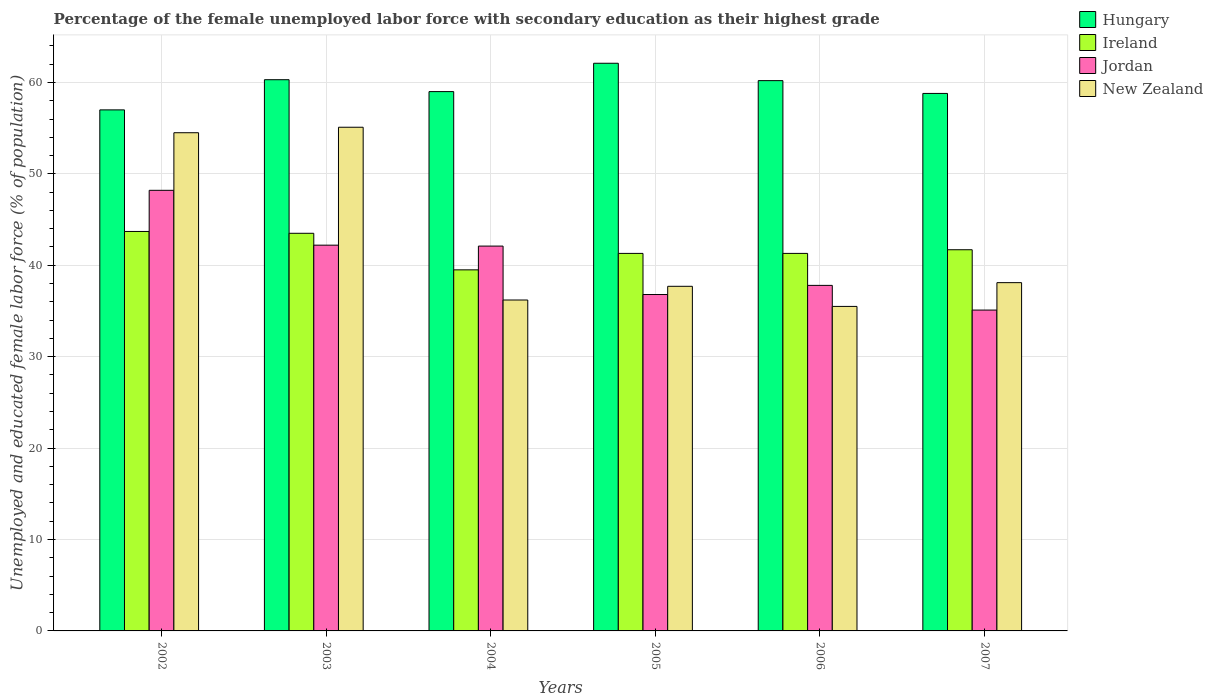How many bars are there on the 4th tick from the left?
Your answer should be very brief. 4. What is the label of the 5th group of bars from the left?
Your response must be concise. 2006. In how many cases, is the number of bars for a given year not equal to the number of legend labels?
Your answer should be compact. 0. What is the percentage of the unemployed female labor force with secondary education in Hungary in 2006?
Make the answer very short. 60.2. Across all years, what is the maximum percentage of the unemployed female labor force with secondary education in Ireland?
Provide a succinct answer. 43.7. In which year was the percentage of the unemployed female labor force with secondary education in New Zealand maximum?
Keep it short and to the point. 2003. What is the total percentage of the unemployed female labor force with secondary education in Hungary in the graph?
Offer a very short reply. 357.4. What is the difference between the percentage of the unemployed female labor force with secondary education in Jordan in 2002 and that in 2006?
Provide a succinct answer. 10.4. What is the difference between the percentage of the unemployed female labor force with secondary education in Ireland in 2007 and the percentage of the unemployed female labor force with secondary education in Jordan in 2004?
Your answer should be very brief. -0.4. What is the average percentage of the unemployed female labor force with secondary education in Jordan per year?
Make the answer very short. 40.37. In the year 2007, what is the difference between the percentage of the unemployed female labor force with secondary education in Ireland and percentage of the unemployed female labor force with secondary education in Hungary?
Your response must be concise. -17.1. In how many years, is the percentage of the unemployed female labor force with secondary education in Jordan greater than 22 %?
Your answer should be compact. 6. What is the ratio of the percentage of the unemployed female labor force with secondary education in Jordan in 2006 to that in 2007?
Your answer should be compact. 1.08. Is the percentage of the unemployed female labor force with secondary education in Jordan in 2003 less than that in 2007?
Keep it short and to the point. No. What is the difference between the highest and the second highest percentage of the unemployed female labor force with secondary education in New Zealand?
Keep it short and to the point. 0.6. What is the difference between the highest and the lowest percentage of the unemployed female labor force with secondary education in Jordan?
Offer a very short reply. 13.1. In how many years, is the percentage of the unemployed female labor force with secondary education in Ireland greater than the average percentage of the unemployed female labor force with secondary education in Ireland taken over all years?
Keep it short and to the point. 2. Is the sum of the percentage of the unemployed female labor force with secondary education in Jordan in 2004 and 2006 greater than the maximum percentage of the unemployed female labor force with secondary education in New Zealand across all years?
Make the answer very short. Yes. What does the 4th bar from the left in 2006 represents?
Ensure brevity in your answer.  New Zealand. What does the 1st bar from the right in 2006 represents?
Keep it short and to the point. New Zealand. Are the values on the major ticks of Y-axis written in scientific E-notation?
Ensure brevity in your answer.  No. Does the graph contain any zero values?
Your response must be concise. No. Does the graph contain grids?
Offer a terse response. Yes. Where does the legend appear in the graph?
Your answer should be compact. Top right. How are the legend labels stacked?
Provide a succinct answer. Vertical. What is the title of the graph?
Give a very brief answer. Percentage of the female unemployed labor force with secondary education as their highest grade. What is the label or title of the Y-axis?
Your response must be concise. Unemployed and educated female labor force (% of population). What is the Unemployed and educated female labor force (% of population) of Ireland in 2002?
Your answer should be compact. 43.7. What is the Unemployed and educated female labor force (% of population) of Jordan in 2002?
Give a very brief answer. 48.2. What is the Unemployed and educated female labor force (% of population) of New Zealand in 2002?
Give a very brief answer. 54.5. What is the Unemployed and educated female labor force (% of population) of Hungary in 2003?
Your answer should be compact. 60.3. What is the Unemployed and educated female labor force (% of population) of Ireland in 2003?
Offer a very short reply. 43.5. What is the Unemployed and educated female labor force (% of population) of Jordan in 2003?
Your answer should be very brief. 42.2. What is the Unemployed and educated female labor force (% of population) of New Zealand in 2003?
Keep it short and to the point. 55.1. What is the Unemployed and educated female labor force (% of population) of Ireland in 2004?
Offer a terse response. 39.5. What is the Unemployed and educated female labor force (% of population) of Jordan in 2004?
Ensure brevity in your answer.  42.1. What is the Unemployed and educated female labor force (% of population) of New Zealand in 2004?
Ensure brevity in your answer.  36.2. What is the Unemployed and educated female labor force (% of population) in Hungary in 2005?
Make the answer very short. 62.1. What is the Unemployed and educated female labor force (% of population) in Ireland in 2005?
Your response must be concise. 41.3. What is the Unemployed and educated female labor force (% of population) of Jordan in 2005?
Offer a very short reply. 36.8. What is the Unemployed and educated female labor force (% of population) of New Zealand in 2005?
Your answer should be very brief. 37.7. What is the Unemployed and educated female labor force (% of population) in Hungary in 2006?
Provide a short and direct response. 60.2. What is the Unemployed and educated female labor force (% of population) of Ireland in 2006?
Your answer should be compact. 41.3. What is the Unemployed and educated female labor force (% of population) of Jordan in 2006?
Make the answer very short. 37.8. What is the Unemployed and educated female labor force (% of population) of New Zealand in 2006?
Your answer should be very brief. 35.5. What is the Unemployed and educated female labor force (% of population) in Hungary in 2007?
Ensure brevity in your answer.  58.8. What is the Unemployed and educated female labor force (% of population) of Ireland in 2007?
Your answer should be very brief. 41.7. What is the Unemployed and educated female labor force (% of population) of Jordan in 2007?
Your response must be concise. 35.1. What is the Unemployed and educated female labor force (% of population) in New Zealand in 2007?
Keep it short and to the point. 38.1. Across all years, what is the maximum Unemployed and educated female labor force (% of population) in Hungary?
Keep it short and to the point. 62.1. Across all years, what is the maximum Unemployed and educated female labor force (% of population) in Ireland?
Keep it short and to the point. 43.7. Across all years, what is the maximum Unemployed and educated female labor force (% of population) in Jordan?
Give a very brief answer. 48.2. Across all years, what is the maximum Unemployed and educated female labor force (% of population) of New Zealand?
Keep it short and to the point. 55.1. Across all years, what is the minimum Unemployed and educated female labor force (% of population) of Hungary?
Ensure brevity in your answer.  57. Across all years, what is the minimum Unemployed and educated female labor force (% of population) of Ireland?
Make the answer very short. 39.5. Across all years, what is the minimum Unemployed and educated female labor force (% of population) in Jordan?
Your answer should be compact. 35.1. Across all years, what is the minimum Unemployed and educated female labor force (% of population) in New Zealand?
Your answer should be very brief. 35.5. What is the total Unemployed and educated female labor force (% of population) of Hungary in the graph?
Give a very brief answer. 357.4. What is the total Unemployed and educated female labor force (% of population) of Ireland in the graph?
Offer a very short reply. 251. What is the total Unemployed and educated female labor force (% of population) in Jordan in the graph?
Provide a short and direct response. 242.2. What is the total Unemployed and educated female labor force (% of population) of New Zealand in the graph?
Offer a very short reply. 257.1. What is the difference between the Unemployed and educated female labor force (% of population) in Hungary in 2002 and that in 2003?
Give a very brief answer. -3.3. What is the difference between the Unemployed and educated female labor force (% of population) of Hungary in 2002 and that in 2004?
Provide a succinct answer. -2. What is the difference between the Unemployed and educated female labor force (% of population) of Ireland in 2002 and that in 2004?
Give a very brief answer. 4.2. What is the difference between the Unemployed and educated female labor force (% of population) of Jordan in 2002 and that in 2004?
Make the answer very short. 6.1. What is the difference between the Unemployed and educated female labor force (% of population) of Hungary in 2002 and that in 2005?
Your answer should be compact. -5.1. What is the difference between the Unemployed and educated female labor force (% of population) of Ireland in 2002 and that in 2005?
Ensure brevity in your answer.  2.4. What is the difference between the Unemployed and educated female labor force (% of population) of New Zealand in 2002 and that in 2005?
Provide a short and direct response. 16.8. What is the difference between the Unemployed and educated female labor force (% of population) in New Zealand in 2002 and that in 2006?
Your response must be concise. 19. What is the difference between the Unemployed and educated female labor force (% of population) in Hungary in 2002 and that in 2007?
Ensure brevity in your answer.  -1.8. What is the difference between the Unemployed and educated female labor force (% of population) of Ireland in 2002 and that in 2007?
Ensure brevity in your answer.  2. What is the difference between the Unemployed and educated female labor force (% of population) in Jordan in 2003 and that in 2004?
Offer a terse response. 0.1. What is the difference between the Unemployed and educated female labor force (% of population) of Hungary in 2003 and that in 2005?
Your response must be concise. -1.8. What is the difference between the Unemployed and educated female labor force (% of population) of Ireland in 2003 and that in 2005?
Provide a short and direct response. 2.2. What is the difference between the Unemployed and educated female labor force (% of population) in Jordan in 2003 and that in 2005?
Give a very brief answer. 5.4. What is the difference between the Unemployed and educated female labor force (% of population) of Hungary in 2003 and that in 2006?
Keep it short and to the point. 0.1. What is the difference between the Unemployed and educated female labor force (% of population) of Ireland in 2003 and that in 2006?
Give a very brief answer. 2.2. What is the difference between the Unemployed and educated female labor force (% of population) of Jordan in 2003 and that in 2006?
Provide a succinct answer. 4.4. What is the difference between the Unemployed and educated female labor force (% of population) of New Zealand in 2003 and that in 2006?
Give a very brief answer. 19.6. What is the difference between the Unemployed and educated female labor force (% of population) in Ireland in 2003 and that in 2007?
Make the answer very short. 1.8. What is the difference between the Unemployed and educated female labor force (% of population) of New Zealand in 2003 and that in 2007?
Provide a succinct answer. 17. What is the difference between the Unemployed and educated female labor force (% of population) in Hungary in 2004 and that in 2005?
Your response must be concise. -3.1. What is the difference between the Unemployed and educated female labor force (% of population) of Ireland in 2004 and that in 2006?
Give a very brief answer. -1.8. What is the difference between the Unemployed and educated female labor force (% of population) in Hungary in 2004 and that in 2007?
Ensure brevity in your answer.  0.2. What is the difference between the Unemployed and educated female labor force (% of population) of Ireland in 2004 and that in 2007?
Ensure brevity in your answer.  -2.2. What is the difference between the Unemployed and educated female labor force (% of population) of Jordan in 2004 and that in 2007?
Keep it short and to the point. 7. What is the difference between the Unemployed and educated female labor force (% of population) in Ireland in 2005 and that in 2006?
Your answer should be very brief. 0. What is the difference between the Unemployed and educated female labor force (% of population) in New Zealand in 2005 and that in 2006?
Offer a terse response. 2.2. What is the difference between the Unemployed and educated female labor force (% of population) in Hungary in 2005 and that in 2007?
Make the answer very short. 3.3. What is the difference between the Unemployed and educated female labor force (% of population) of Jordan in 2005 and that in 2007?
Offer a very short reply. 1.7. What is the difference between the Unemployed and educated female labor force (% of population) in New Zealand in 2005 and that in 2007?
Offer a terse response. -0.4. What is the difference between the Unemployed and educated female labor force (% of population) in Hungary in 2006 and that in 2007?
Offer a very short reply. 1.4. What is the difference between the Unemployed and educated female labor force (% of population) in Hungary in 2002 and the Unemployed and educated female labor force (% of population) in Ireland in 2003?
Ensure brevity in your answer.  13.5. What is the difference between the Unemployed and educated female labor force (% of population) in Jordan in 2002 and the Unemployed and educated female labor force (% of population) in New Zealand in 2003?
Offer a very short reply. -6.9. What is the difference between the Unemployed and educated female labor force (% of population) in Hungary in 2002 and the Unemployed and educated female labor force (% of population) in Ireland in 2004?
Your answer should be very brief. 17.5. What is the difference between the Unemployed and educated female labor force (% of population) of Hungary in 2002 and the Unemployed and educated female labor force (% of population) of New Zealand in 2004?
Your answer should be compact. 20.8. What is the difference between the Unemployed and educated female labor force (% of population) of Hungary in 2002 and the Unemployed and educated female labor force (% of population) of Ireland in 2005?
Provide a succinct answer. 15.7. What is the difference between the Unemployed and educated female labor force (% of population) of Hungary in 2002 and the Unemployed and educated female labor force (% of population) of Jordan in 2005?
Your answer should be very brief. 20.2. What is the difference between the Unemployed and educated female labor force (% of population) in Hungary in 2002 and the Unemployed and educated female labor force (% of population) in New Zealand in 2005?
Keep it short and to the point. 19.3. What is the difference between the Unemployed and educated female labor force (% of population) of Hungary in 2002 and the Unemployed and educated female labor force (% of population) of New Zealand in 2006?
Offer a terse response. 21.5. What is the difference between the Unemployed and educated female labor force (% of population) of Ireland in 2002 and the Unemployed and educated female labor force (% of population) of Jordan in 2006?
Provide a succinct answer. 5.9. What is the difference between the Unemployed and educated female labor force (% of population) of Hungary in 2002 and the Unemployed and educated female labor force (% of population) of Ireland in 2007?
Your response must be concise. 15.3. What is the difference between the Unemployed and educated female labor force (% of population) of Hungary in 2002 and the Unemployed and educated female labor force (% of population) of Jordan in 2007?
Your response must be concise. 21.9. What is the difference between the Unemployed and educated female labor force (% of population) in Jordan in 2002 and the Unemployed and educated female labor force (% of population) in New Zealand in 2007?
Your answer should be very brief. 10.1. What is the difference between the Unemployed and educated female labor force (% of population) in Hungary in 2003 and the Unemployed and educated female labor force (% of population) in Ireland in 2004?
Keep it short and to the point. 20.8. What is the difference between the Unemployed and educated female labor force (% of population) of Hungary in 2003 and the Unemployed and educated female labor force (% of population) of Jordan in 2004?
Give a very brief answer. 18.2. What is the difference between the Unemployed and educated female labor force (% of population) in Hungary in 2003 and the Unemployed and educated female labor force (% of population) in New Zealand in 2004?
Keep it short and to the point. 24.1. What is the difference between the Unemployed and educated female labor force (% of population) of Ireland in 2003 and the Unemployed and educated female labor force (% of population) of New Zealand in 2004?
Give a very brief answer. 7.3. What is the difference between the Unemployed and educated female labor force (% of population) in Hungary in 2003 and the Unemployed and educated female labor force (% of population) in Ireland in 2005?
Give a very brief answer. 19. What is the difference between the Unemployed and educated female labor force (% of population) in Hungary in 2003 and the Unemployed and educated female labor force (% of population) in New Zealand in 2005?
Provide a short and direct response. 22.6. What is the difference between the Unemployed and educated female labor force (% of population) of Ireland in 2003 and the Unemployed and educated female labor force (% of population) of Jordan in 2005?
Provide a succinct answer. 6.7. What is the difference between the Unemployed and educated female labor force (% of population) in Jordan in 2003 and the Unemployed and educated female labor force (% of population) in New Zealand in 2005?
Give a very brief answer. 4.5. What is the difference between the Unemployed and educated female labor force (% of population) of Hungary in 2003 and the Unemployed and educated female labor force (% of population) of Jordan in 2006?
Ensure brevity in your answer.  22.5. What is the difference between the Unemployed and educated female labor force (% of population) in Hungary in 2003 and the Unemployed and educated female labor force (% of population) in New Zealand in 2006?
Give a very brief answer. 24.8. What is the difference between the Unemployed and educated female labor force (% of population) in Ireland in 2003 and the Unemployed and educated female labor force (% of population) in Jordan in 2006?
Give a very brief answer. 5.7. What is the difference between the Unemployed and educated female labor force (% of population) of Hungary in 2003 and the Unemployed and educated female labor force (% of population) of Ireland in 2007?
Offer a very short reply. 18.6. What is the difference between the Unemployed and educated female labor force (% of population) in Hungary in 2003 and the Unemployed and educated female labor force (% of population) in Jordan in 2007?
Your answer should be very brief. 25.2. What is the difference between the Unemployed and educated female labor force (% of population) in Ireland in 2003 and the Unemployed and educated female labor force (% of population) in Jordan in 2007?
Make the answer very short. 8.4. What is the difference between the Unemployed and educated female labor force (% of population) of Ireland in 2003 and the Unemployed and educated female labor force (% of population) of New Zealand in 2007?
Offer a very short reply. 5.4. What is the difference between the Unemployed and educated female labor force (% of population) in Jordan in 2003 and the Unemployed and educated female labor force (% of population) in New Zealand in 2007?
Your answer should be compact. 4.1. What is the difference between the Unemployed and educated female labor force (% of population) of Hungary in 2004 and the Unemployed and educated female labor force (% of population) of Jordan in 2005?
Your response must be concise. 22.2. What is the difference between the Unemployed and educated female labor force (% of population) in Hungary in 2004 and the Unemployed and educated female labor force (% of population) in New Zealand in 2005?
Your response must be concise. 21.3. What is the difference between the Unemployed and educated female labor force (% of population) of Ireland in 2004 and the Unemployed and educated female labor force (% of population) of Jordan in 2005?
Ensure brevity in your answer.  2.7. What is the difference between the Unemployed and educated female labor force (% of population) in Ireland in 2004 and the Unemployed and educated female labor force (% of population) in New Zealand in 2005?
Offer a very short reply. 1.8. What is the difference between the Unemployed and educated female labor force (% of population) of Jordan in 2004 and the Unemployed and educated female labor force (% of population) of New Zealand in 2005?
Make the answer very short. 4.4. What is the difference between the Unemployed and educated female labor force (% of population) of Hungary in 2004 and the Unemployed and educated female labor force (% of population) of Ireland in 2006?
Your answer should be very brief. 17.7. What is the difference between the Unemployed and educated female labor force (% of population) in Hungary in 2004 and the Unemployed and educated female labor force (% of population) in Jordan in 2006?
Make the answer very short. 21.2. What is the difference between the Unemployed and educated female labor force (% of population) of Hungary in 2004 and the Unemployed and educated female labor force (% of population) of New Zealand in 2006?
Offer a terse response. 23.5. What is the difference between the Unemployed and educated female labor force (% of population) in Ireland in 2004 and the Unemployed and educated female labor force (% of population) in New Zealand in 2006?
Offer a very short reply. 4. What is the difference between the Unemployed and educated female labor force (% of population) in Hungary in 2004 and the Unemployed and educated female labor force (% of population) in Jordan in 2007?
Provide a succinct answer. 23.9. What is the difference between the Unemployed and educated female labor force (% of population) in Hungary in 2004 and the Unemployed and educated female labor force (% of population) in New Zealand in 2007?
Provide a short and direct response. 20.9. What is the difference between the Unemployed and educated female labor force (% of population) in Ireland in 2004 and the Unemployed and educated female labor force (% of population) in Jordan in 2007?
Your answer should be very brief. 4.4. What is the difference between the Unemployed and educated female labor force (% of population) in Jordan in 2004 and the Unemployed and educated female labor force (% of population) in New Zealand in 2007?
Ensure brevity in your answer.  4. What is the difference between the Unemployed and educated female labor force (% of population) of Hungary in 2005 and the Unemployed and educated female labor force (% of population) of Ireland in 2006?
Offer a very short reply. 20.8. What is the difference between the Unemployed and educated female labor force (% of population) of Hungary in 2005 and the Unemployed and educated female labor force (% of population) of Jordan in 2006?
Your answer should be very brief. 24.3. What is the difference between the Unemployed and educated female labor force (% of population) in Hungary in 2005 and the Unemployed and educated female labor force (% of population) in New Zealand in 2006?
Make the answer very short. 26.6. What is the difference between the Unemployed and educated female labor force (% of population) in Ireland in 2005 and the Unemployed and educated female labor force (% of population) in Jordan in 2006?
Your answer should be very brief. 3.5. What is the difference between the Unemployed and educated female labor force (% of population) in Ireland in 2005 and the Unemployed and educated female labor force (% of population) in New Zealand in 2006?
Offer a terse response. 5.8. What is the difference between the Unemployed and educated female labor force (% of population) in Jordan in 2005 and the Unemployed and educated female labor force (% of population) in New Zealand in 2006?
Provide a short and direct response. 1.3. What is the difference between the Unemployed and educated female labor force (% of population) of Hungary in 2005 and the Unemployed and educated female labor force (% of population) of Ireland in 2007?
Offer a very short reply. 20.4. What is the difference between the Unemployed and educated female labor force (% of population) of Ireland in 2005 and the Unemployed and educated female labor force (% of population) of Jordan in 2007?
Your response must be concise. 6.2. What is the difference between the Unemployed and educated female labor force (% of population) of Hungary in 2006 and the Unemployed and educated female labor force (% of population) of Ireland in 2007?
Your answer should be compact. 18.5. What is the difference between the Unemployed and educated female labor force (% of population) of Hungary in 2006 and the Unemployed and educated female labor force (% of population) of Jordan in 2007?
Give a very brief answer. 25.1. What is the difference between the Unemployed and educated female labor force (% of population) of Hungary in 2006 and the Unemployed and educated female labor force (% of population) of New Zealand in 2007?
Your answer should be very brief. 22.1. What is the average Unemployed and educated female labor force (% of population) of Hungary per year?
Give a very brief answer. 59.57. What is the average Unemployed and educated female labor force (% of population) in Ireland per year?
Provide a succinct answer. 41.83. What is the average Unemployed and educated female labor force (% of population) of Jordan per year?
Provide a short and direct response. 40.37. What is the average Unemployed and educated female labor force (% of population) of New Zealand per year?
Offer a very short reply. 42.85. In the year 2002, what is the difference between the Unemployed and educated female labor force (% of population) of Hungary and Unemployed and educated female labor force (% of population) of Ireland?
Ensure brevity in your answer.  13.3. In the year 2002, what is the difference between the Unemployed and educated female labor force (% of population) in Ireland and Unemployed and educated female labor force (% of population) in Jordan?
Your answer should be very brief. -4.5. In the year 2002, what is the difference between the Unemployed and educated female labor force (% of population) in Jordan and Unemployed and educated female labor force (% of population) in New Zealand?
Offer a terse response. -6.3. In the year 2003, what is the difference between the Unemployed and educated female labor force (% of population) in Hungary and Unemployed and educated female labor force (% of population) in Ireland?
Your answer should be very brief. 16.8. In the year 2003, what is the difference between the Unemployed and educated female labor force (% of population) in Ireland and Unemployed and educated female labor force (% of population) in Jordan?
Make the answer very short. 1.3. In the year 2003, what is the difference between the Unemployed and educated female labor force (% of population) in Ireland and Unemployed and educated female labor force (% of population) in New Zealand?
Provide a succinct answer. -11.6. In the year 2003, what is the difference between the Unemployed and educated female labor force (% of population) of Jordan and Unemployed and educated female labor force (% of population) of New Zealand?
Make the answer very short. -12.9. In the year 2004, what is the difference between the Unemployed and educated female labor force (% of population) of Hungary and Unemployed and educated female labor force (% of population) of Jordan?
Provide a short and direct response. 16.9. In the year 2004, what is the difference between the Unemployed and educated female labor force (% of population) of Hungary and Unemployed and educated female labor force (% of population) of New Zealand?
Make the answer very short. 22.8. In the year 2004, what is the difference between the Unemployed and educated female labor force (% of population) in Ireland and Unemployed and educated female labor force (% of population) in New Zealand?
Your response must be concise. 3.3. In the year 2005, what is the difference between the Unemployed and educated female labor force (% of population) of Hungary and Unemployed and educated female labor force (% of population) of Ireland?
Keep it short and to the point. 20.8. In the year 2005, what is the difference between the Unemployed and educated female labor force (% of population) of Hungary and Unemployed and educated female labor force (% of population) of Jordan?
Make the answer very short. 25.3. In the year 2005, what is the difference between the Unemployed and educated female labor force (% of population) of Hungary and Unemployed and educated female labor force (% of population) of New Zealand?
Your response must be concise. 24.4. In the year 2005, what is the difference between the Unemployed and educated female labor force (% of population) of Jordan and Unemployed and educated female labor force (% of population) of New Zealand?
Keep it short and to the point. -0.9. In the year 2006, what is the difference between the Unemployed and educated female labor force (% of population) of Hungary and Unemployed and educated female labor force (% of population) of Jordan?
Offer a very short reply. 22.4. In the year 2006, what is the difference between the Unemployed and educated female labor force (% of population) of Hungary and Unemployed and educated female labor force (% of population) of New Zealand?
Offer a terse response. 24.7. In the year 2006, what is the difference between the Unemployed and educated female labor force (% of population) in Ireland and Unemployed and educated female labor force (% of population) in New Zealand?
Ensure brevity in your answer.  5.8. In the year 2006, what is the difference between the Unemployed and educated female labor force (% of population) of Jordan and Unemployed and educated female labor force (% of population) of New Zealand?
Your answer should be compact. 2.3. In the year 2007, what is the difference between the Unemployed and educated female labor force (% of population) in Hungary and Unemployed and educated female labor force (% of population) in Ireland?
Your answer should be compact. 17.1. In the year 2007, what is the difference between the Unemployed and educated female labor force (% of population) of Hungary and Unemployed and educated female labor force (% of population) of Jordan?
Ensure brevity in your answer.  23.7. In the year 2007, what is the difference between the Unemployed and educated female labor force (% of population) in Hungary and Unemployed and educated female labor force (% of population) in New Zealand?
Provide a succinct answer. 20.7. In the year 2007, what is the difference between the Unemployed and educated female labor force (% of population) of Ireland and Unemployed and educated female labor force (% of population) of Jordan?
Give a very brief answer. 6.6. What is the ratio of the Unemployed and educated female labor force (% of population) in Hungary in 2002 to that in 2003?
Provide a short and direct response. 0.95. What is the ratio of the Unemployed and educated female labor force (% of population) in Ireland in 2002 to that in 2003?
Offer a very short reply. 1. What is the ratio of the Unemployed and educated female labor force (% of population) in Jordan in 2002 to that in 2003?
Provide a succinct answer. 1.14. What is the ratio of the Unemployed and educated female labor force (% of population) of Hungary in 2002 to that in 2004?
Provide a short and direct response. 0.97. What is the ratio of the Unemployed and educated female labor force (% of population) of Ireland in 2002 to that in 2004?
Provide a succinct answer. 1.11. What is the ratio of the Unemployed and educated female labor force (% of population) in Jordan in 2002 to that in 2004?
Make the answer very short. 1.14. What is the ratio of the Unemployed and educated female labor force (% of population) of New Zealand in 2002 to that in 2004?
Your response must be concise. 1.51. What is the ratio of the Unemployed and educated female labor force (% of population) of Hungary in 2002 to that in 2005?
Make the answer very short. 0.92. What is the ratio of the Unemployed and educated female labor force (% of population) in Ireland in 2002 to that in 2005?
Make the answer very short. 1.06. What is the ratio of the Unemployed and educated female labor force (% of population) of Jordan in 2002 to that in 2005?
Keep it short and to the point. 1.31. What is the ratio of the Unemployed and educated female labor force (% of population) of New Zealand in 2002 to that in 2005?
Your answer should be very brief. 1.45. What is the ratio of the Unemployed and educated female labor force (% of population) in Hungary in 2002 to that in 2006?
Offer a very short reply. 0.95. What is the ratio of the Unemployed and educated female labor force (% of population) of Ireland in 2002 to that in 2006?
Your response must be concise. 1.06. What is the ratio of the Unemployed and educated female labor force (% of population) in Jordan in 2002 to that in 2006?
Offer a very short reply. 1.28. What is the ratio of the Unemployed and educated female labor force (% of population) of New Zealand in 2002 to that in 2006?
Give a very brief answer. 1.54. What is the ratio of the Unemployed and educated female labor force (% of population) of Hungary in 2002 to that in 2007?
Your answer should be very brief. 0.97. What is the ratio of the Unemployed and educated female labor force (% of population) of Ireland in 2002 to that in 2007?
Ensure brevity in your answer.  1.05. What is the ratio of the Unemployed and educated female labor force (% of population) of Jordan in 2002 to that in 2007?
Ensure brevity in your answer.  1.37. What is the ratio of the Unemployed and educated female labor force (% of population) in New Zealand in 2002 to that in 2007?
Your response must be concise. 1.43. What is the ratio of the Unemployed and educated female labor force (% of population) of Ireland in 2003 to that in 2004?
Make the answer very short. 1.1. What is the ratio of the Unemployed and educated female labor force (% of population) in New Zealand in 2003 to that in 2004?
Your answer should be compact. 1.52. What is the ratio of the Unemployed and educated female labor force (% of population) of Ireland in 2003 to that in 2005?
Offer a terse response. 1.05. What is the ratio of the Unemployed and educated female labor force (% of population) in Jordan in 2003 to that in 2005?
Your answer should be compact. 1.15. What is the ratio of the Unemployed and educated female labor force (% of population) in New Zealand in 2003 to that in 2005?
Provide a succinct answer. 1.46. What is the ratio of the Unemployed and educated female labor force (% of population) in Hungary in 2003 to that in 2006?
Ensure brevity in your answer.  1. What is the ratio of the Unemployed and educated female labor force (% of population) of Ireland in 2003 to that in 2006?
Offer a very short reply. 1.05. What is the ratio of the Unemployed and educated female labor force (% of population) of Jordan in 2003 to that in 2006?
Your answer should be very brief. 1.12. What is the ratio of the Unemployed and educated female labor force (% of population) in New Zealand in 2003 to that in 2006?
Your answer should be compact. 1.55. What is the ratio of the Unemployed and educated female labor force (% of population) in Hungary in 2003 to that in 2007?
Offer a terse response. 1.03. What is the ratio of the Unemployed and educated female labor force (% of population) in Ireland in 2003 to that in 2007?
Your answer should be very brief. 1.04. What is the ratio of the Unemployed and educated female labor force (% of population) in Jordan in 2003 to that in 2007?
Give a very brief answer. 1.2. What is the ratio of the Unemployed and educated female labor force (% of population) in New Zealand in 2003 to that in 2007?
Keep it short and to the point. 1.45. What is the ratio of the Unemployed and educated female labor force (% of population) of Hungary in 2004 to that in 2005?
Ensure brevity in your answer.  0.95. What is the ratio of the Unemployed and educated female labor force (% of population) of Ireland in 2004 to that in 2005?
Your answer should be compact. 0.96. What is the ratio of the Unemployed and educated female labor force (% of population) in Jordan in 2004 to that in 2005?
Offer a terse response. 1.14. What is the ratio of the Unemployed and educated female labor force (% of population) in New Zealand in 2004 to that in 2005?
Your response must be concise. 0.96. What is the ratio of the Unemployed and educated female labor force (% of population) of Hungary in 2004 to that in 2006?
Ensure brevity in your answer.  0.98. What is the ratio of the Unemployed and educated female labor force (% of population) of Ireland in 2004 to that in 2006?
Provide a succinct answer. 0.96. What is the ratio of the Unemployed and educated female labor force (% of population) of Jordan in 2004 to that in 2006?
Make the answer very short. 1.11. What is the ratio of the Unemployed and educated female labor force (% of population) in New Zealand in 2004 to that in 2006?
Provide a succinct answer. 1.02. What is the ratio of the Unemployed and educated female labor force (% of population) in Ireland in 2004 to that in 2007?
Your answer should be very brief. 0.95. What is the ratio of the Unemployed and educated female labor force (% of population) of Jordan in 2004 to that in 2007?
Offer a very short reply. 1.2. What is the ratio of the Unemployed and educated female labor force (% of population) in New Zealand in 2004 to that in 2007?
Your answer should be very brief. 0.95. What is the ratio of the Unemployed and educated female labor force (% of population) in Hungary in 2005 to that in 2006?
Your answer should be very brief. 1.03. What is the ratio of the Unemployed and educated female labor force (% of population) of Jordan in 2005 to that in 2006?
Ensure brevity in your answer.  0.97. What is the ratio of the Unemployed and educated female labor force (% of population) of New Zealand in 2005 to that in 2006?
Your answer should be very brief. 1.06. What is the ratio of the Unemployed and educated female labor force (% of population) in Hungary in 2005 to that in 2007?
Give a very brief answer. 1.06. What is the ratio of the Unemployed and educated female labor force (% of population) in Ireland in 2005 to that in 2007?
Your answer should be compact. 0.99. What is the ratio of the Unemployed and educated female labor force (% of population) in Jordan in 2005 to that in 2007?
Your answer should be very brief. 1.05. What is the ratio of the Unemployed and educated female labor force (% of population) of New Zealand in 2005 to that in 2007?
Offer a very short reply. 0.99. What is the ratio of the Unemployed and educated female labor force (% of population) in Hungary in 2006 to that in 2007?
Offer a terse response. 1.02. What is the ratio of the Unemployed and educated female labor force (% of population) in Ireland in 2006 to that in 2007?
Keep it short and to the point. 0.99. What is the ratio of the Unemployed and educated female labor force (% of population) of Jordan in 2006 to that in 2007?
Keep it short and to the point. 1.08. What is the ratio of the Unemployed and educated female labor force (% of population) of New Zealand in 2006 to that in 2007?
Give a very brief answer. 0.93. What is the difference between the highest and the second highest Unemployed and educated female labor force (% of population) of Hungary?
Your answer should be compact. 1.8. What is the difference between the highest and the second highest Unemployed and educated female labor force (% of population) of Ireland?
Provide a succinct answer. 0.2. What is the difference between the highest and the second highest Unemployed and educated female labor force (% of population) of Jordan?
Offer a terse response. 6. What is the difference between the highest and the lowest Unemployed and educated female labor force (% of population) of Ireland?
Keep it short and to the point. 4.2. What is the difference between the highest and the lowest Unemployed and educated female labor force (% of population) of Jordan?
Your answer should be very brief. 13.1. What is the difference between the highest and the lowest Unemployed and educated female labor force (% of population) of New Zealand?
Give a very brief answer. 19.6. 